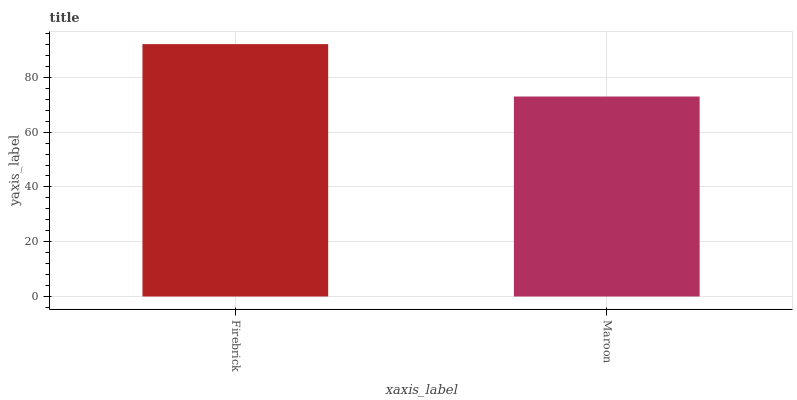Is Maroon the minimum?
Answer yes or no. Yes. Is Firebrick the maximum?
Answer yes or no. Yes. Is Maroon the maximum?
Answer yes or no. No. Is Firebrick greater than Maroon?
Answer yes or no. Yes. Is Maroon less than Firebrick?
Answer yes or no. Yes. Is Maroon greater than Firebrick?
Answer yes or no. No. Is Firebrick less than Maroon?
Answer yes or no. No. Is Firebrick the high median?
Answer yes or no. Yes. Is Maroon the low median?
Answer yes or no. Yes. Is Maroon the high median?
Answer yes or no. No. Is Firebrick the low median?
Answer yes or no. No. 